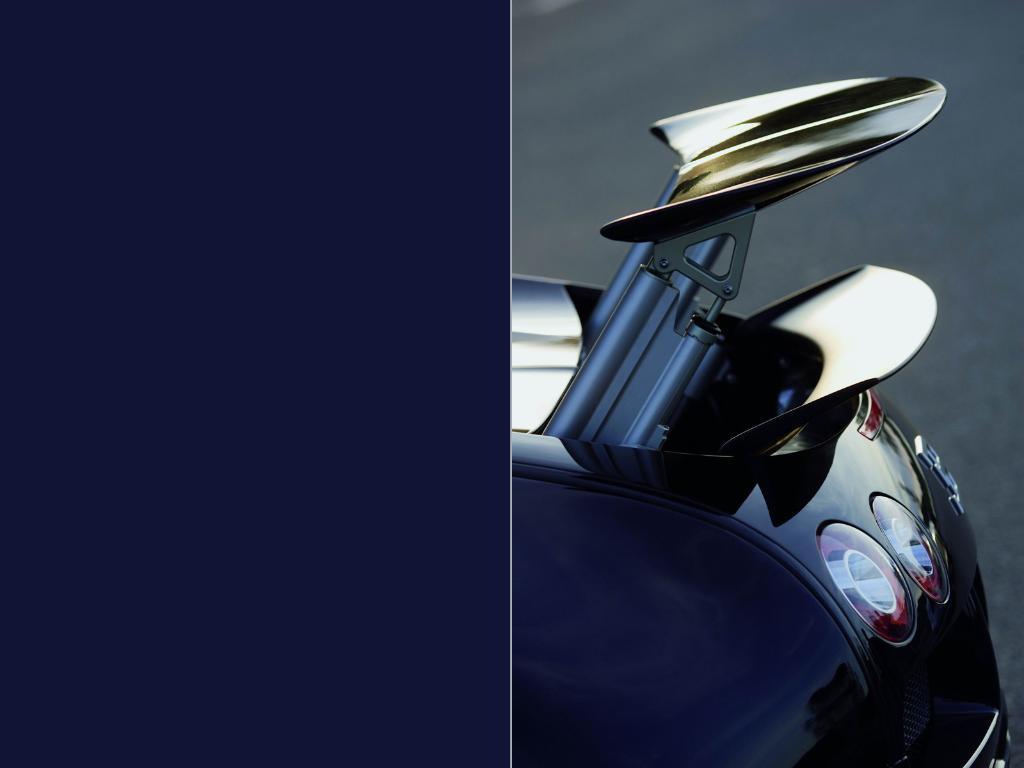Could you give a brief overview of what you see in this image? In the picture I can see collage of an image and there is an object in the right corner and there is blue color in the left corner. 